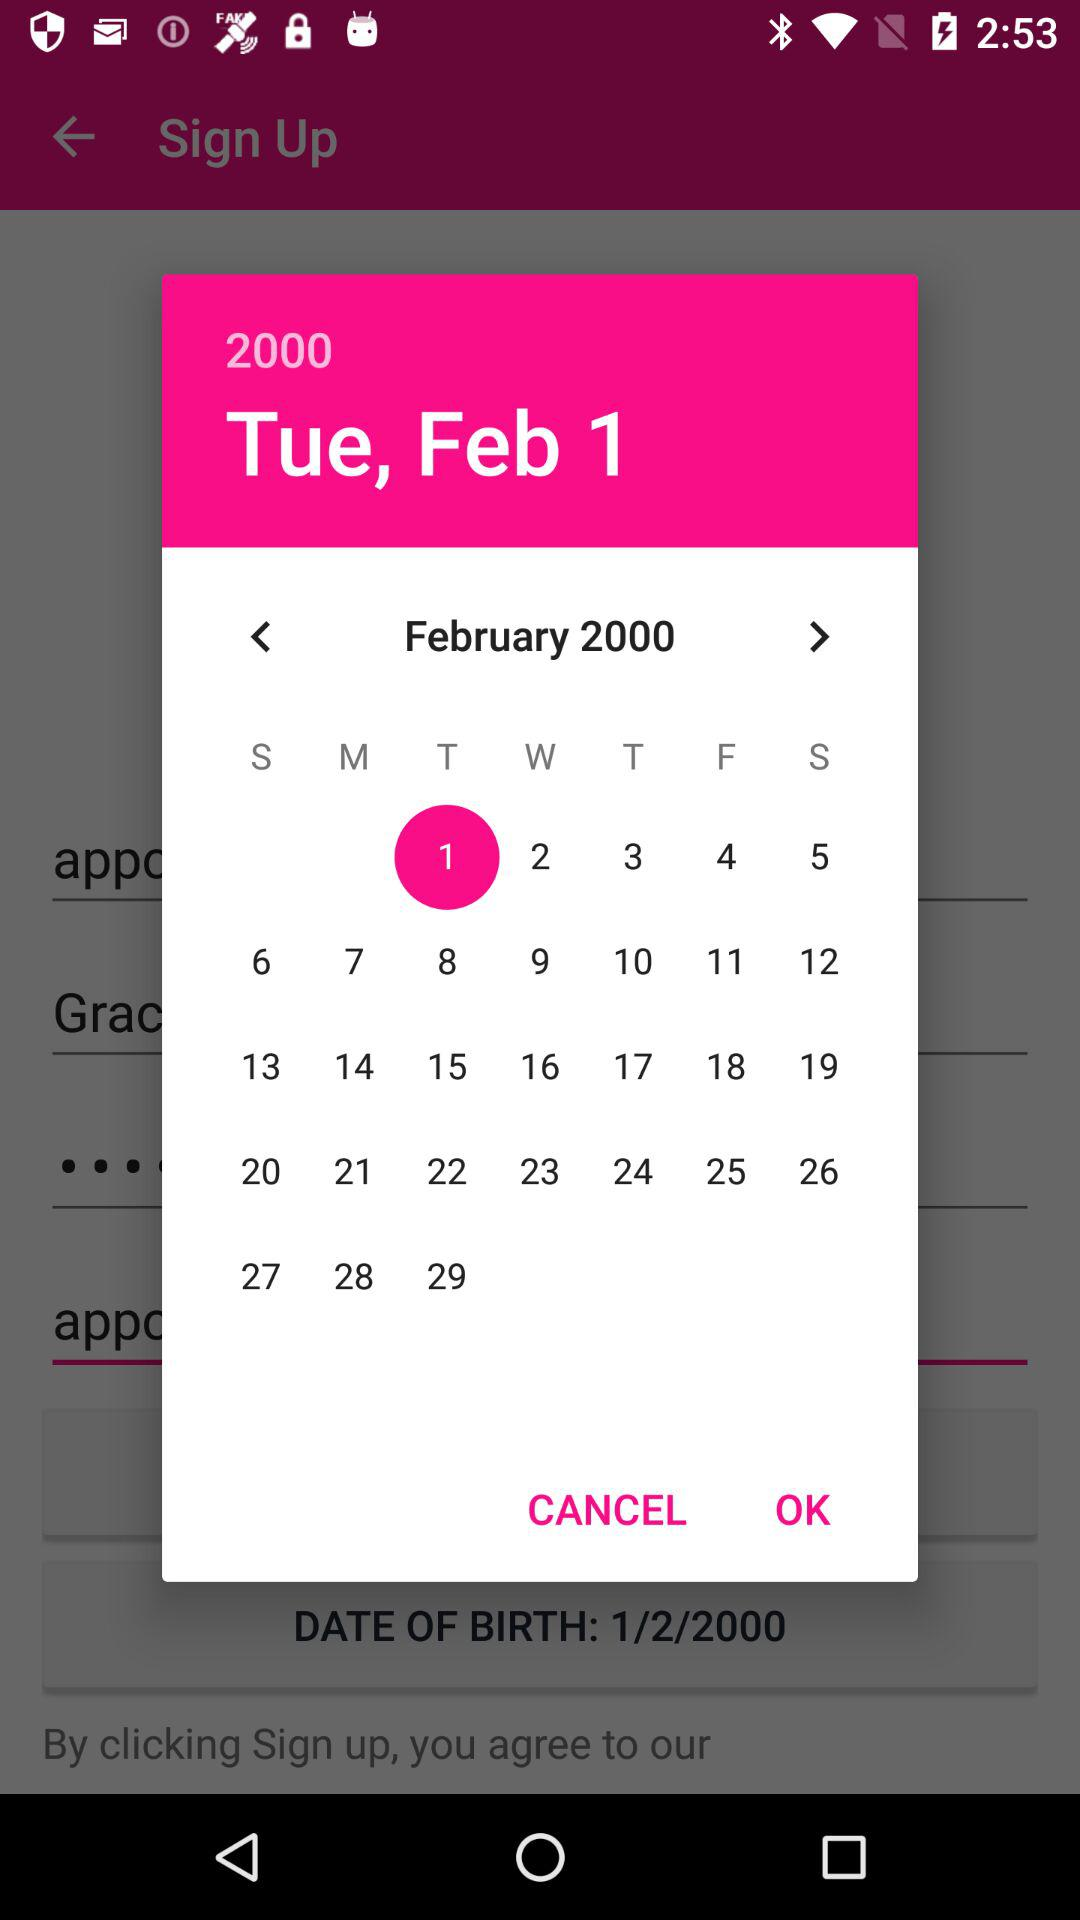Which day is on March 1, 2000?
When the provided information is insufficient, respond with <no answer>. <no answer> 